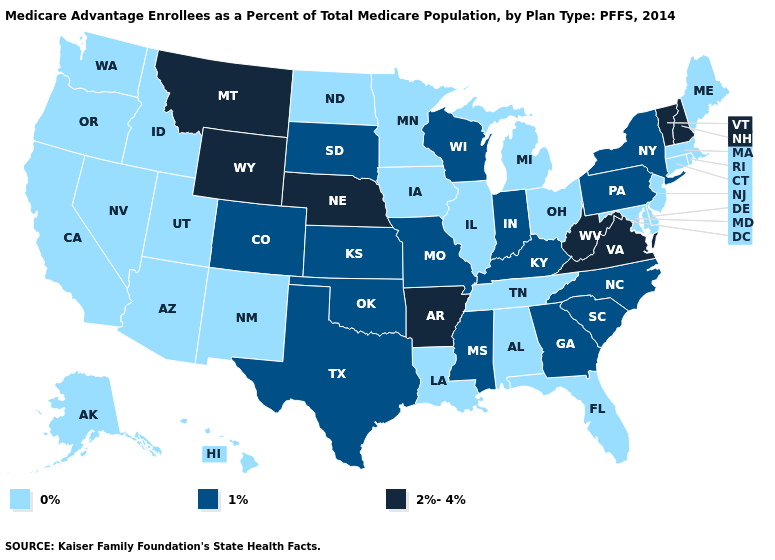What is the value of Arizona?
Write a very short answer. 0%. Name the states that have a value in the range 1%?
Quick response, please. Colorado, Georgia, Indiana, Kansas, Kentucky, Missouri, Mississippi, North Carolina, New York, Oklahoma, Pennsylvania, South Carolina, South Dakota, Texas, Wisconsin. How many symbols are there in the legend?
Concise answer only. 3. Name the states that have a value in the range 1%?
Quick response, please. Colorado, Georgia, Indiana, Kansas, Kentucky, Missouri, Mississippi, North Carolina, New York, Oklahoma, Pennsylvania, South Carolina, South Dakota, Texas, Wisconsin. Name the states that have a value in the range 0%?
Short answer required. Alaska, Alabama, Arizona, California, Connecticut, Delaware, Florida, Hawaii, Iowa, Idaho, Illinois, Louisiana, Massachusetts, Maryland, Maine, Michigan, Minnesota, North Dakota, New Jersey, New Mexico, Nevada, Ohio, Oregon, Rhode Island, Tennessee, Utah, Washington. Name the states that have a value in the range 0%?
Write a very short answer. Alaska, Alabama, Arizona, California, Connecticut, Delaware, Florida, Hawaii, Iowa, Idaho, Illinois, Louisiana, Massachusetts, Maryland, Maine, Michigan, Minnesota, North Dakota, New Jersey, New Mexico, Nevada, Ohio, Oregon, Rhode Island, Tennessee, Utah, Washington. Name the states that have a value in the range 0%?
Concise answer only. Alaska, Alabama, Arizona, California, Connecticut, Delaware, Florida, Hawaii, Iowa, Idaho, Illinois, Louisiana, Massachusetts, Maryland, Maine, Michigan, Minnesota, North Dakota, New Jersey, New Mexico, Nevada, Ohio, Oregon, Rhode Island, Tennessee, Utah, Washington. Name the states that have a value in the range 1%?
Give a very brief answer. Colorado, Georgia, Indiana, Kansas, Kentucky, Missouri, Mississippi, North Carolina, New York, Oklahoma, Pennsylvania, South Carolina, South Dakota, Texas, Wisconsin. Does Iowa have the same value as New Hampshire?
Quick response, please. No. What is the value of Alabama?
Answer briefly. 0%. Among the states that border Kansas , does Nebraska have the highest value?
Give a very brief answer. Yes. What is the value of Massachusetts?
Be succinct. 0%. What is the value of Virginia?
Be succinct. 2%-4%. Which states have the lowest value in the USA?
Answer briefly. Alaska, Alabama, Arizona, California, Connecticut, Delaware, Florida, Hawaii, Iowa, Idaho, Illinois, Louisiana, Massachusetts, Maryland, Maine, Michigan, Minnesota, North Dakota, New Jersey, New Mexico, Nevada, Ohio, Oregon, Rhode Island, Tennessee, Utah, Washington. Among the states that border Arkansas , does Tennessee have the highest value?
Be succinct. No. 